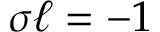Convert formula to latex. <formula><loc_0><loc_0><loc_500><loc_500>\sigma \ell = - 1</formula> 